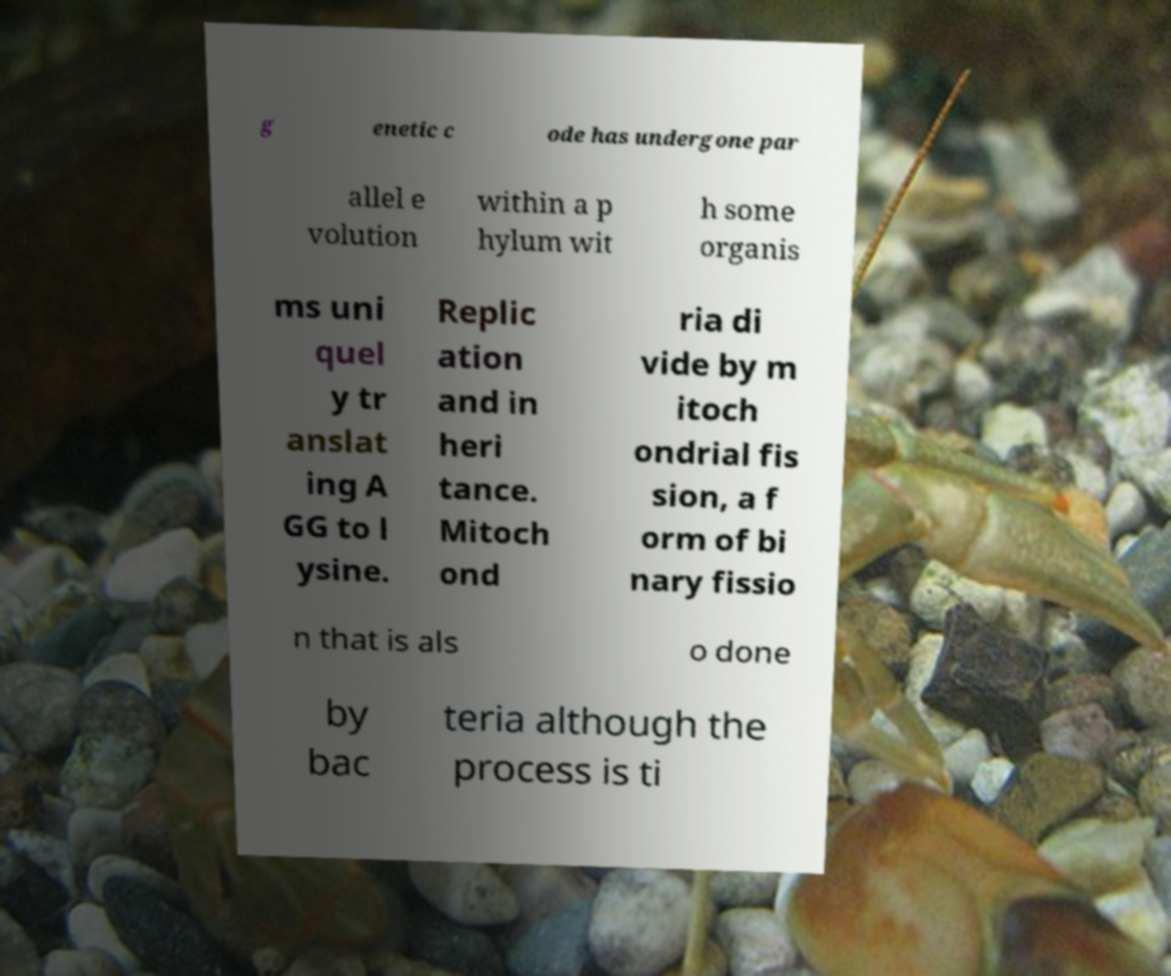I need the written content from this picture converted into text. Can you do that? g enetic c ode has undergone par allel e volution within a p hylum wit h some organis ms uni quel y tr anslat ing A GG to l ysine. Replic ation and in heri tance. Mitoch ond ria di vide by m itoch ondrial fis sion, a f orm of bi nary fissio n that is als o done by bac teria although the process is ti 